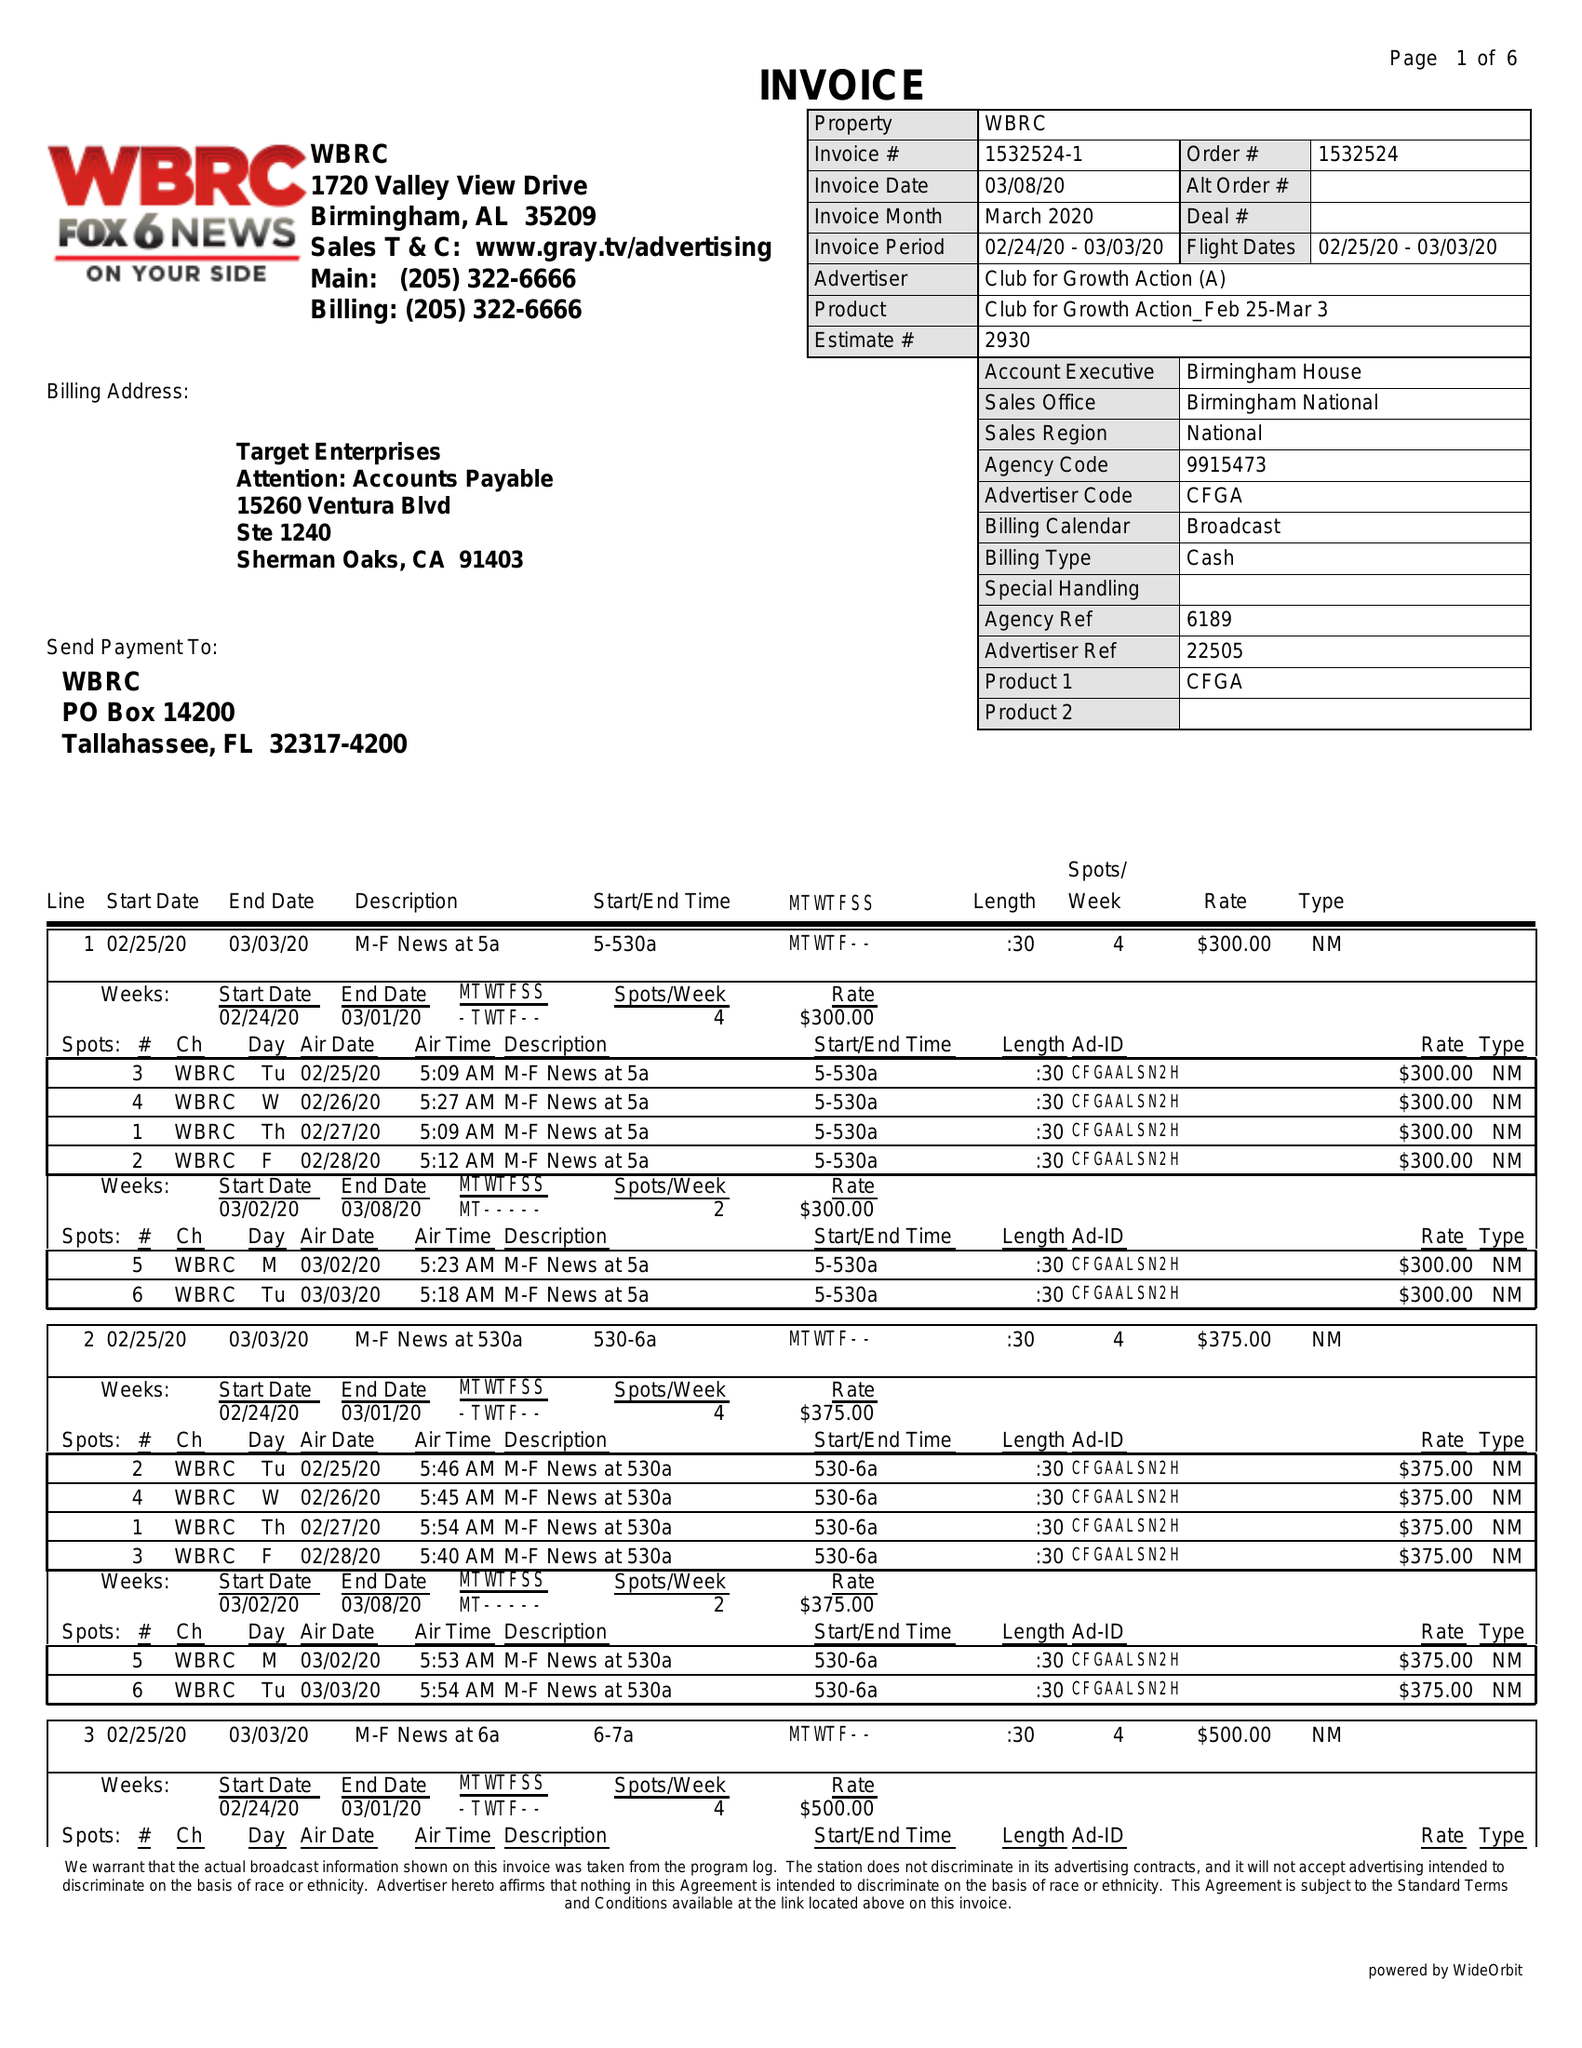What is the value for the advertiser?
Answer the question using a single word or phrase. CLUB FOR GROWTH ACTION 